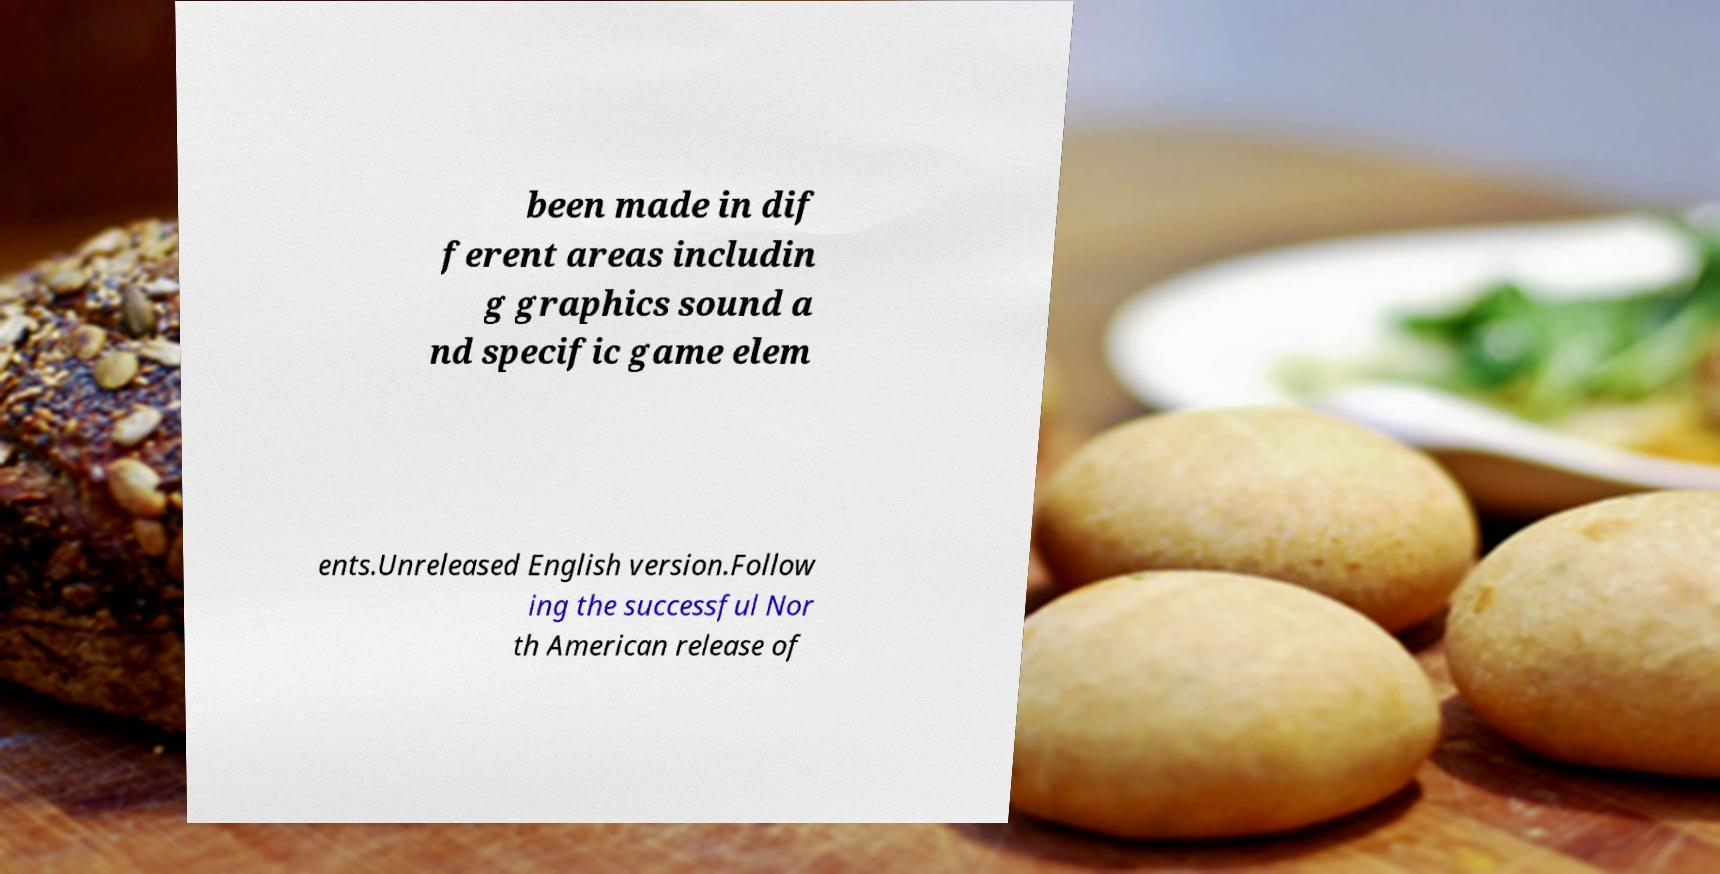Please identify and transcribe the text found in this image. been made in dif ferent areas includin g graphics sound a nd specific game elem ents.Unreleased English version.Follow ing the successful Nor th American release of 